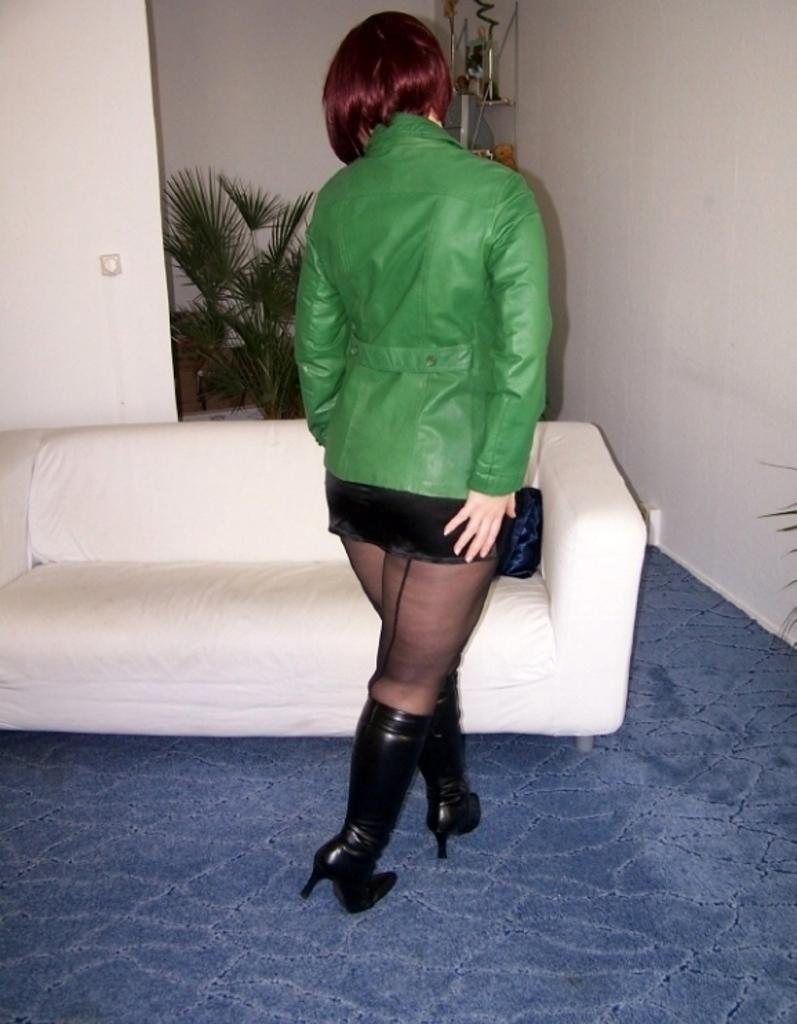Please provide a concise description of this image. In this image I see a woman who is wearing green jacket and I see that she is also wearing black color heels and I see the floor which is of blue in color and I see a white color couch over here. In the background I see the white wall and I see the plants. 